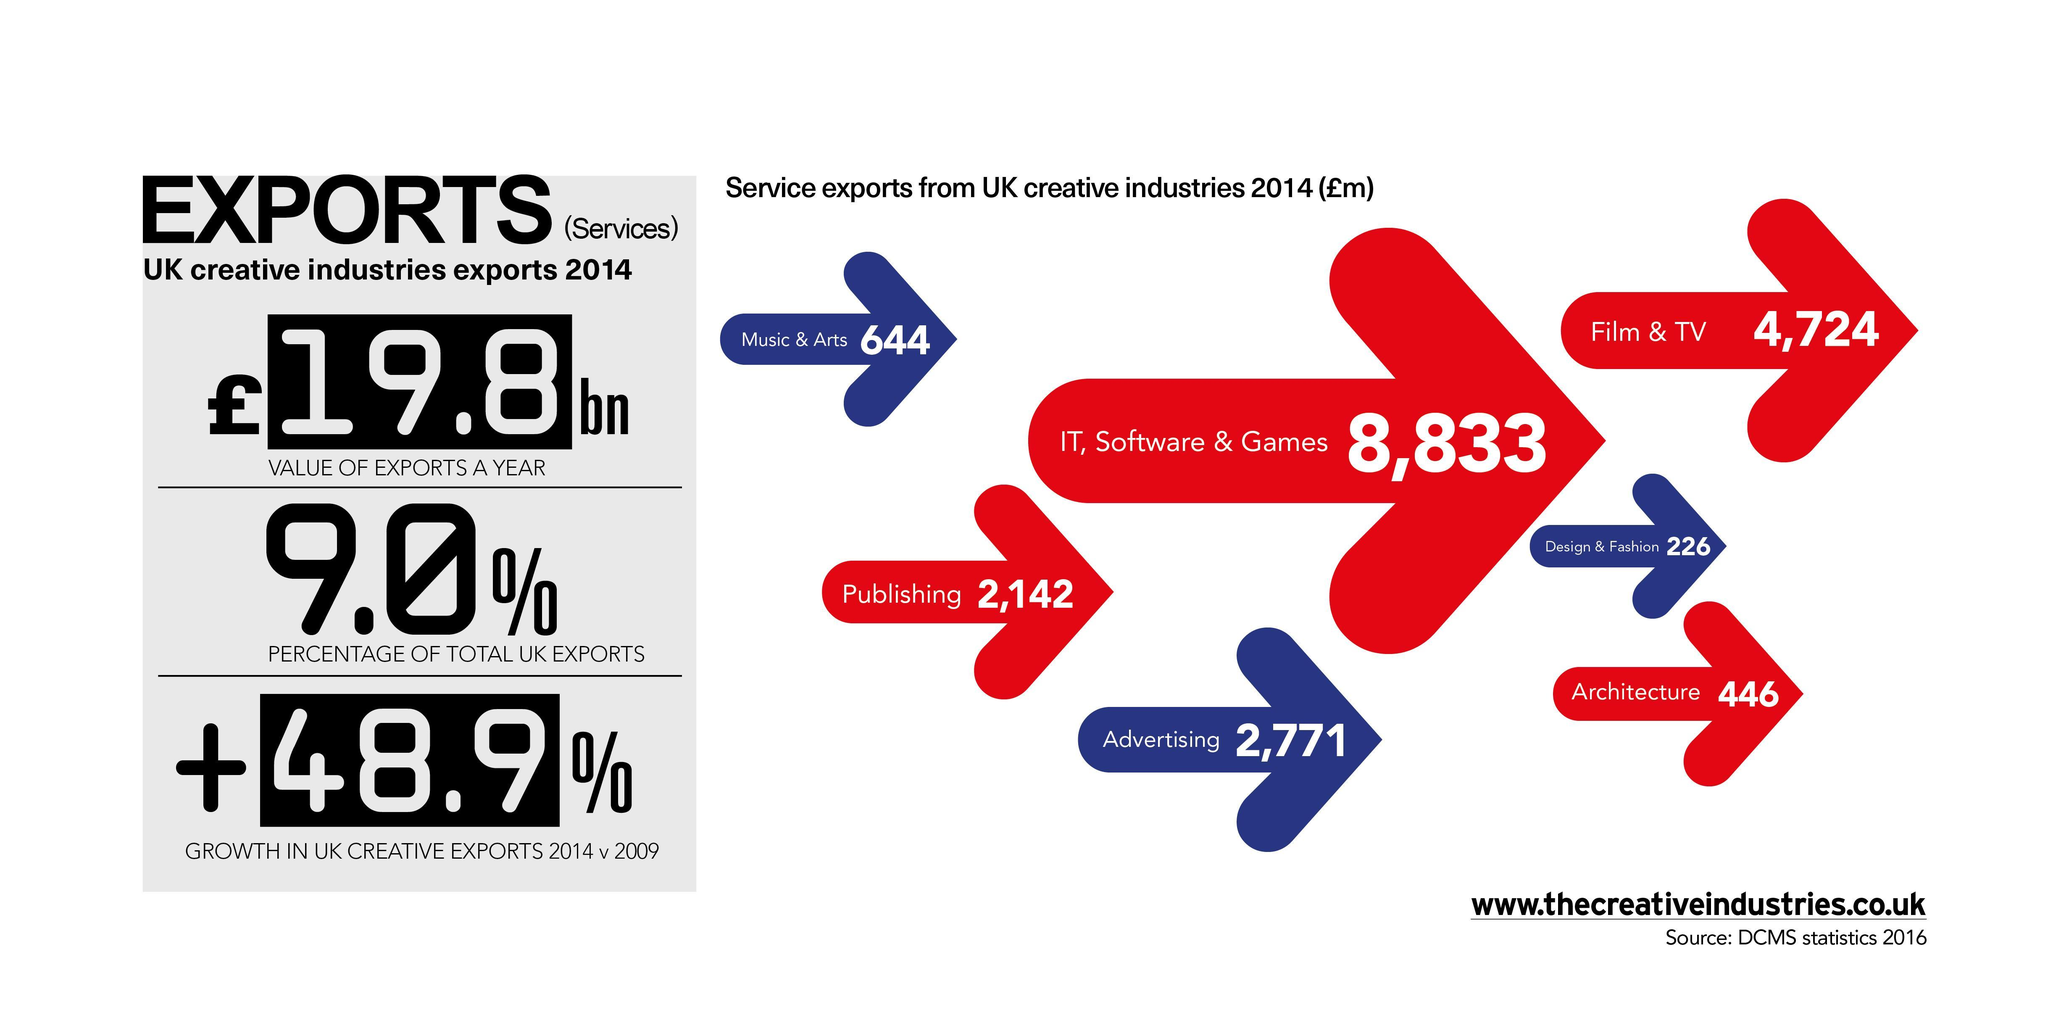Which area has highest service exports from UK creative industries?
Answer the question with a short phrase. IT, Software & Games Which area has the least exports from UK creative industries? Design & Fashion 